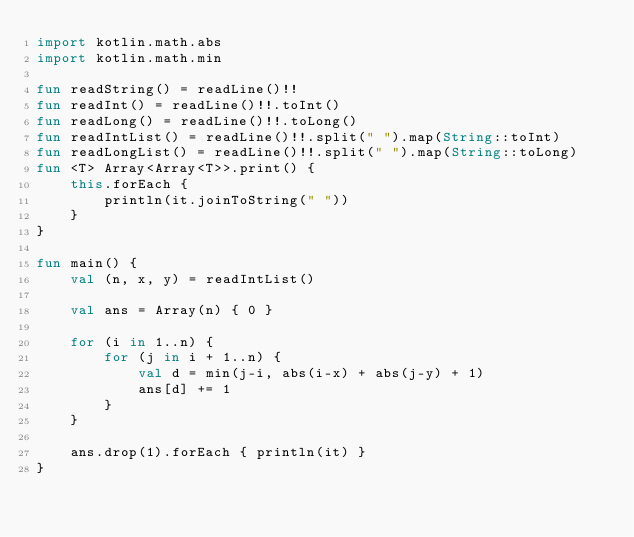<code> <loc_0><loc_0><loc_500><loc_500><_Kotlin_>import kotlin.math.abs
import kotlin.math.min

fun readString() = readLine()!!
fun readInt() = readLine()!!.toInt()
fun readLong() = readLine()!!.toLong()
fun readIntList() = readLine()!!.split(" ").map(String::toInt)
fun readLongList() = readLine()!!.split(" ").map(String::toLong)
fun <T> Array<Array<T>>.print() {
    this.forEach {
        println(it.joinToString(" "))
    }
}

fun main() {
    val (n, x, y) = readIntList()

    val ans = Array(n) { 0 }

    for (i in 1..n) {
        for (j in i + 1..n) {
            val d = min(j-i, abs(i-x) + abs(j-y) + 1)
            ans[d] += 1
        }
    }

    ans.drop(1).forEach { println(it) }
}
</code> 